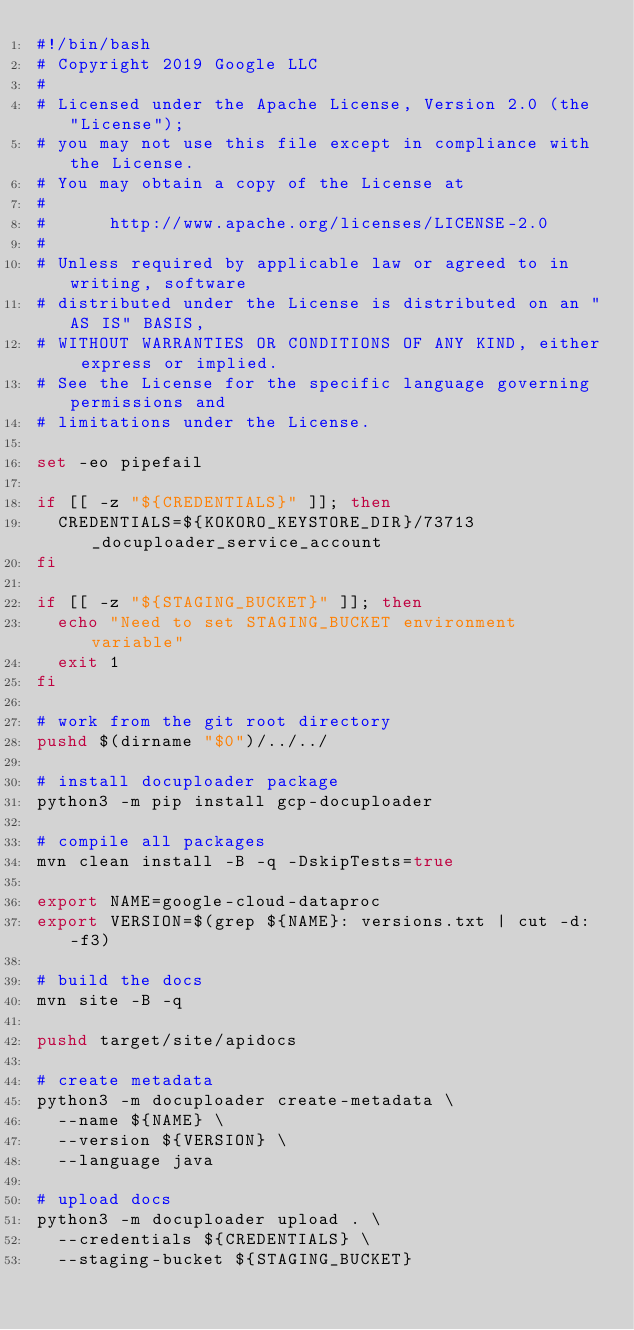Convert code to text. <code><loc_0><loc_0><loc_500><loc_500><_Bash_>#!/bin/bash
# Copyright 2019 Google LLC
#
# Licensed under the Apache License, Version 2.0 (the "License");
# you may not use this file except in compliance with the License.
# You may obtain a copy of the License at
#
#      http://www.apache.org/licenses/LICENSE-2.0
#
# Unless required by applicable law or agreed to in writing, software
# distributed under the License is distributed on an "AS IS" BASIS,
# WITHOUT WARRANTIES OR CONDITIONS OF ANY KIND, either express or implied.
# See the License for the specific language governing permissions and
# limitations under the License.

set -eo pipefail

if [[ -z "${CREDENTIALS}" ]]; then
  CREDENTIALS=${KOKORO_KEYSTORE_DIR}/73713_docuploader_service_account
fi

if [[ -z "${STAGING_BUCKET}" ]]; then
  echo "Need to set STAGING_BUCKET environment variable"
  exit 1
fi

# work from the git root directory
pushd $(dirname "$0")/../../

# install docuploader package
python3 -m pip install gcp-docuploader

# compile all packages
mvn clean install -B -q -DskipTests=true

export NAME=google-cloud-dataproc
export VERSION=$(grep ${NAME}: versions.txt | cut -d: -f3)

# build the docs
mvn site -B -q

pushd target/site/apidocs

# create metadata
python3 -m docuploader create-metadata \
  --name ${NAME} \
  --version ${VERSION} \
  --language java

# upload docs
python3 -m docuploader upload . \
  --credentials ${CREDENTIALS} \
  --staging-bucket ${STAGING_BUCKET}
</code> 